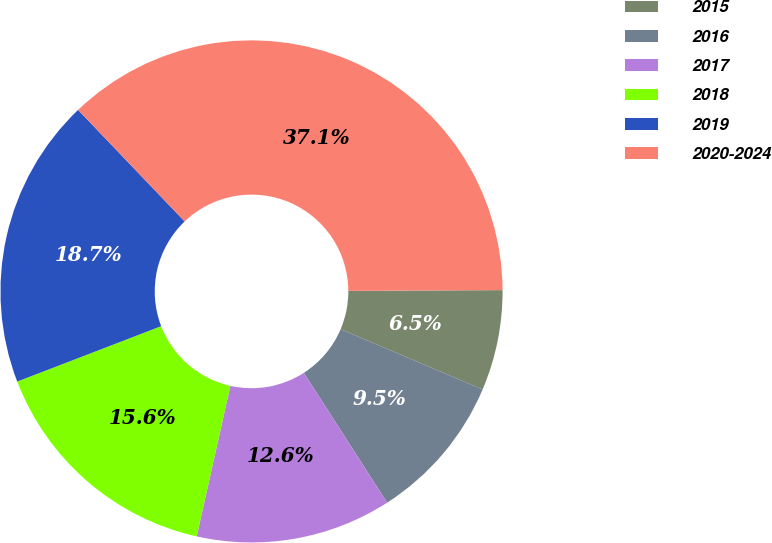Convert chart to OTSL. <chart><loc_0><loc_0><loc_500><loc_500><pie_chart><fcel>2015<fcel>2016<fcel>2017<fcel>2018<fcel>2019<fcel>2020-2024<nl><fcel>6.47%<fcel>9.53%<fcel>12.59%<fcel>15.65%<fcel>18.71%<fcel>37.06%<nl></chart> 